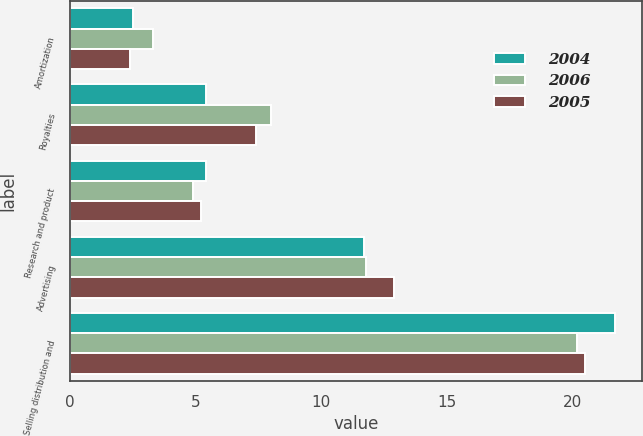Convert chart to OTSL. <chart><loc_0><loc_0><loc_500><loc_500><stacked_bar_chart><ecel><fcel>Amortization<fcel>Royalties<fcel>Research and product<fcel>Advertising<fcel>Selling distribution and<nl><fcel>2004<fcel>2.5<fcel>5.4<fcel>5.4<fcel>11.7<fcel>21.7<nl><fcel>2006<fcel>3.3<fcel>8<fcel>4.9<fcel>11.8<fcel>20.2<nl><fcel>2005<fcel>2.4<fcel>7.4<fcel>5.2<fcel>12.9<fcel>20.5<nl></chart> 